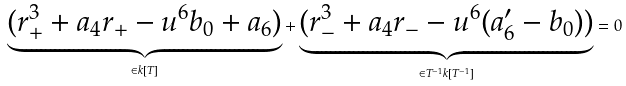Convert formula to latex. <formula><loc_0><loc_0><loc_500><loc_500>\underbrace { ( r _ { + } ^ { 3 } + a _ { 4 } r _ { + } - u ^ { 6 } b _ { 0 } + a _ { 6 } ) } _ { \in k [ T ] } + \underbrace { ( r _ { - } ^ { 3 } + a _ { 4 } r _ { - } - u ^ { 6 } ( a ^ { \prime } _ { 6 } - b _ { 0 } ) ) } _ { \in T ^ { - 1 } k [ T ^ { - 1 } ] } = 0</formula> 